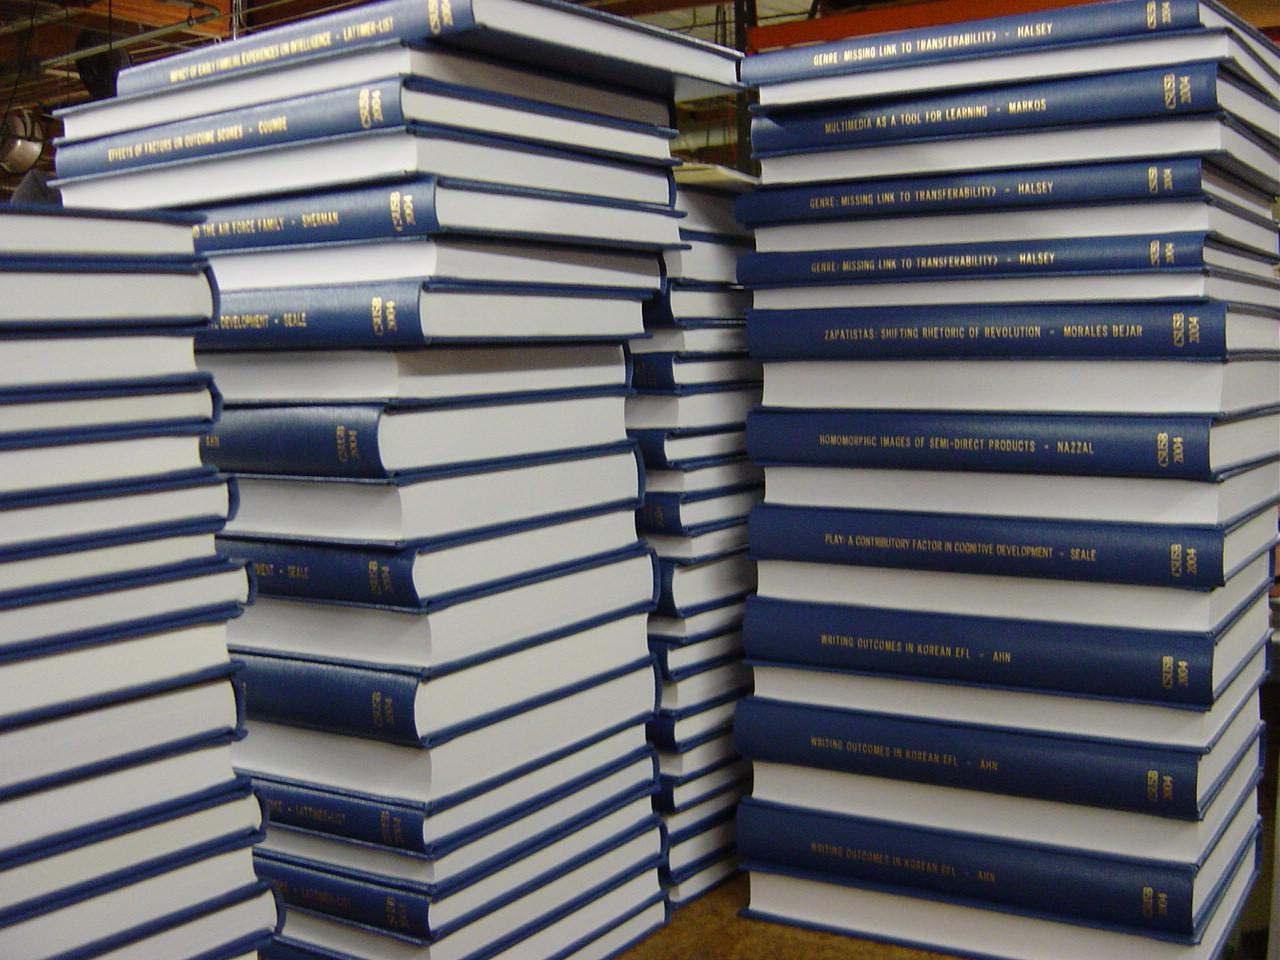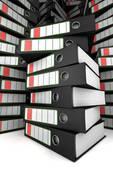The first image is the image on the left, the second image is the image on the right. Assess this claim about the two images: "In one of the images there are stacks of books not on a shelf.". Correct or not? Answer yes or no. Yes. The first image is the image on the left, the second image is the image on the right. Assess this claim about the two images: "One image shows binders of various colors arranged vertically on tiered shelves.". Correct or not? Answer yes or no. No. 